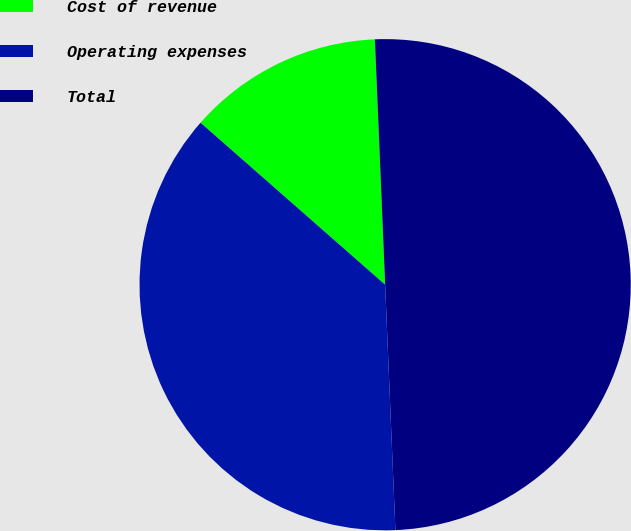Convert chart to OTSL. <chart><loc_0><loc_0><loc_500><loc_500><pie_chart><fcel>Cost of revenue<fcel>Operating expenses<fcel>Total<nl><fcel>12.87%<fcel>37.13%<fcel>50.0%<nl></chart> 